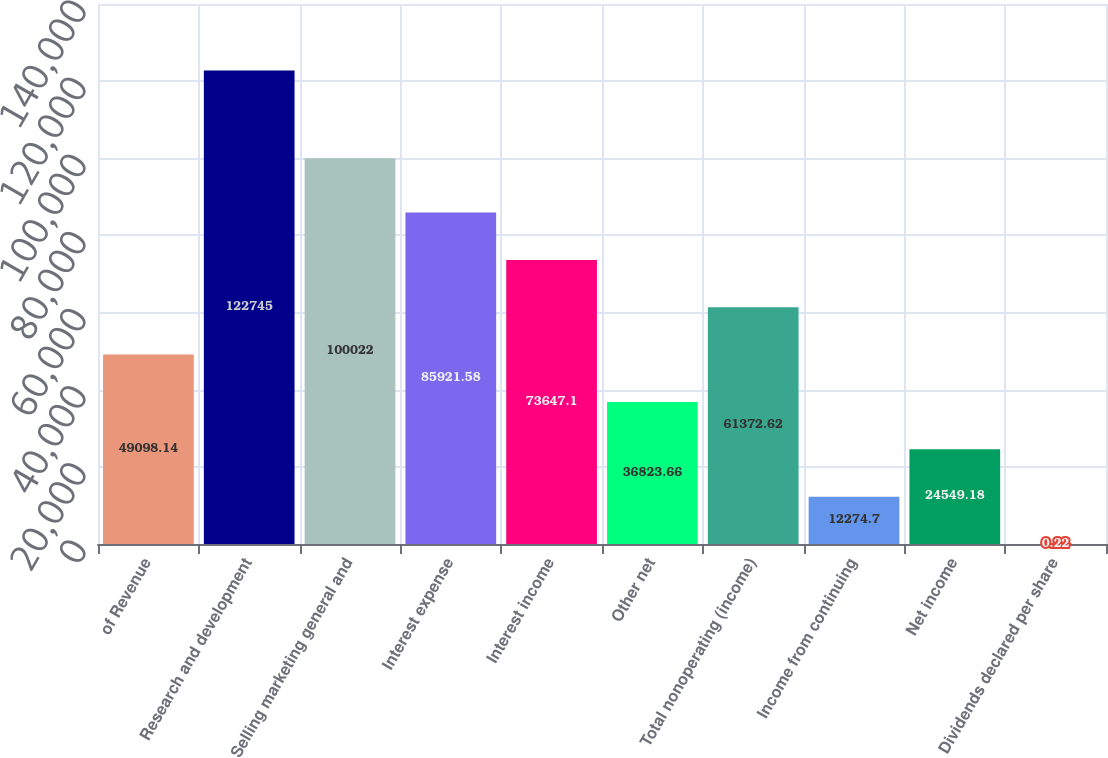<chart> <loc_0><loc_0><loc_500><loc_500><bar_chart><fcel>of Revenue<fcel>Research and development<fcel>Selling marketing general and<fcel>Interest expense<fcel>Interest income<fcel>Other net<fcel>Total nonoperating (income)<fcel>Income from continuing<fcel>Net income<fcel>Dividends declared per share<nl><fcel>49098.1<fcel>122745<fcel>100022<fcel>85921.6<fcel>73647.1<fcel>36823.7<fcel>61372.6<fcel>12274.7<fcel>24549.2<fcel>0.22<nl></chart> 